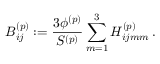<formula> <loc_0><loc_0><loc_500><loc_500>B _ { i j } ^ { ( p ) } \colon = \frac { 3 \phi ^ { ( p ) } } { S ^ { ( p ) } } \sum _ { m = 1 } ^ { 3 } H _ { i j m m } ^ { ( p ) } \, .</formula> 